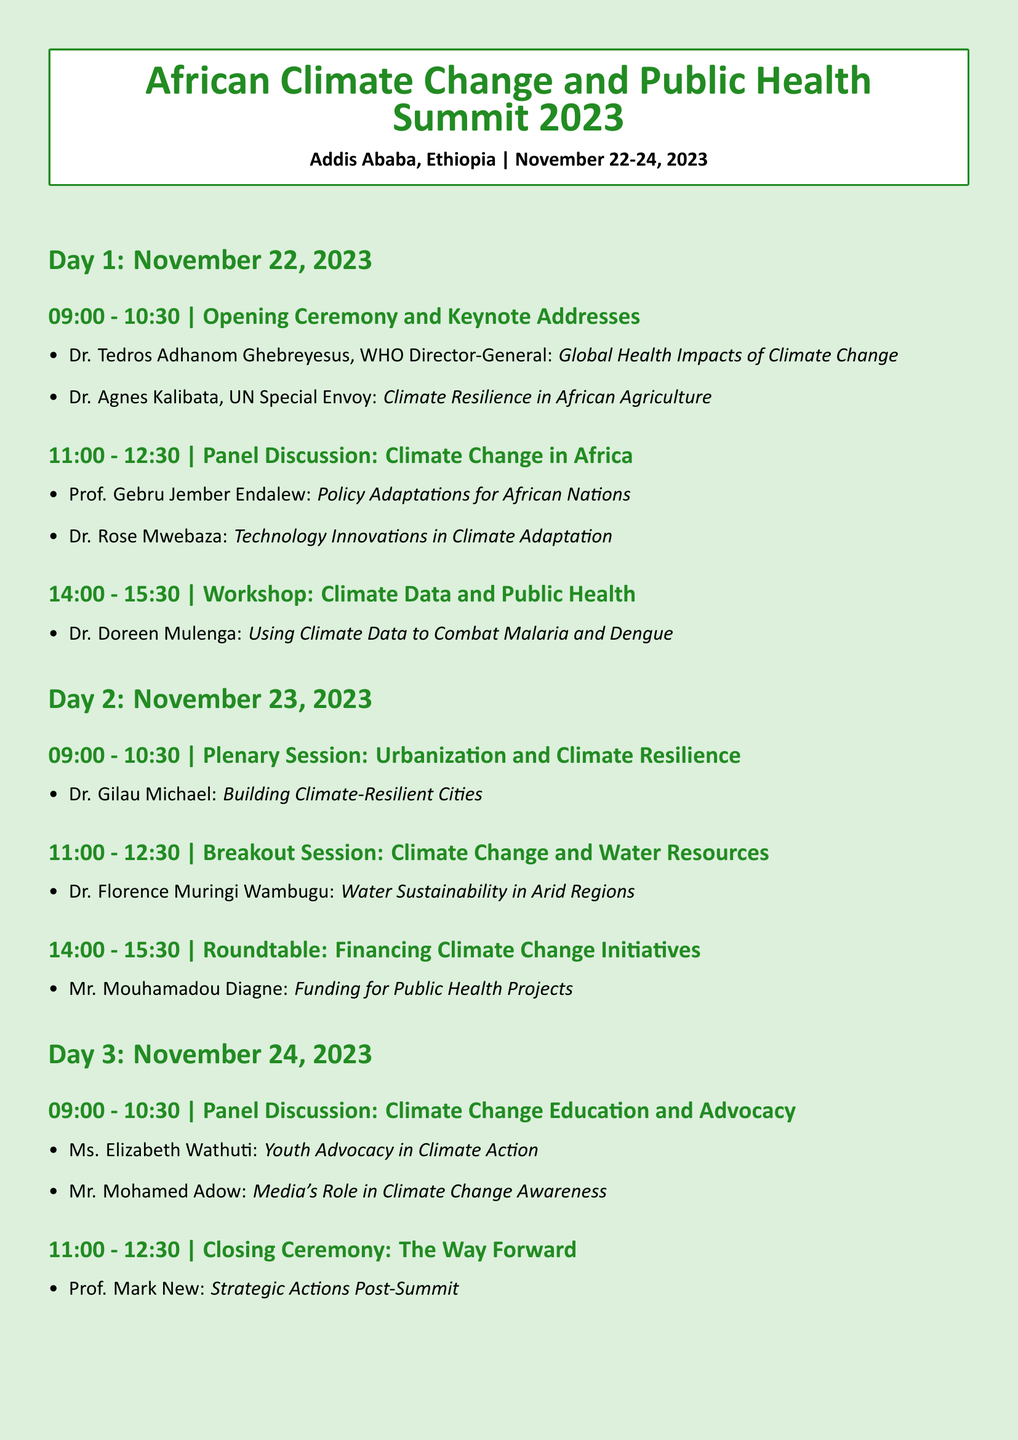what are the dates of the summit? The document specifies that the summit will take place from November 22-24, 2023.
Answer: November 22-24, 2023 who will deliver the keynote address on the impacts of climate change? The keynote address on global health impacts will be given by Dr. Tedros Adhanom Ghebreyesus, WHO Director-General.
Answer: Dr. Tedros Adhanom Ghebreyesus what is the focus of the workshop presented by Dr. Doreen Mulenga? The workshop will focus on using climate data to combat malaria and dengue.
Answer: Using Climate Data to Combat Malaria and Dengue which topic is addressed in the plenary session on November 23? The plenary session will address urbanization and climate resilience, as stated in the document.
Answer: Urbanization and Climate Resilience who is speaking about youth advocacy in climate action? Ms. Elizabeth Wathuti will speak about youth advocacy in climate action during the panel discussion.
Answer: Ms. Elizabeth Wathuti what topic will Dr. Florence Muringi Wambugu cover? The breakout session will focus on water sustainability in arid regions.
Answer: Water Sustainability in Arid Regions when will the closing ceremony take place? The closing ceremony is scheduled on November 24 from 11:00 - 12:30.
Answer: November 24, 11:00 - 12:30 who discusses funding for public health projects during the roundtable? Mr. Mouhamadou Diagne will discuss funding for public health projects.
Answer: Mr. Mouhamadou Diagne 